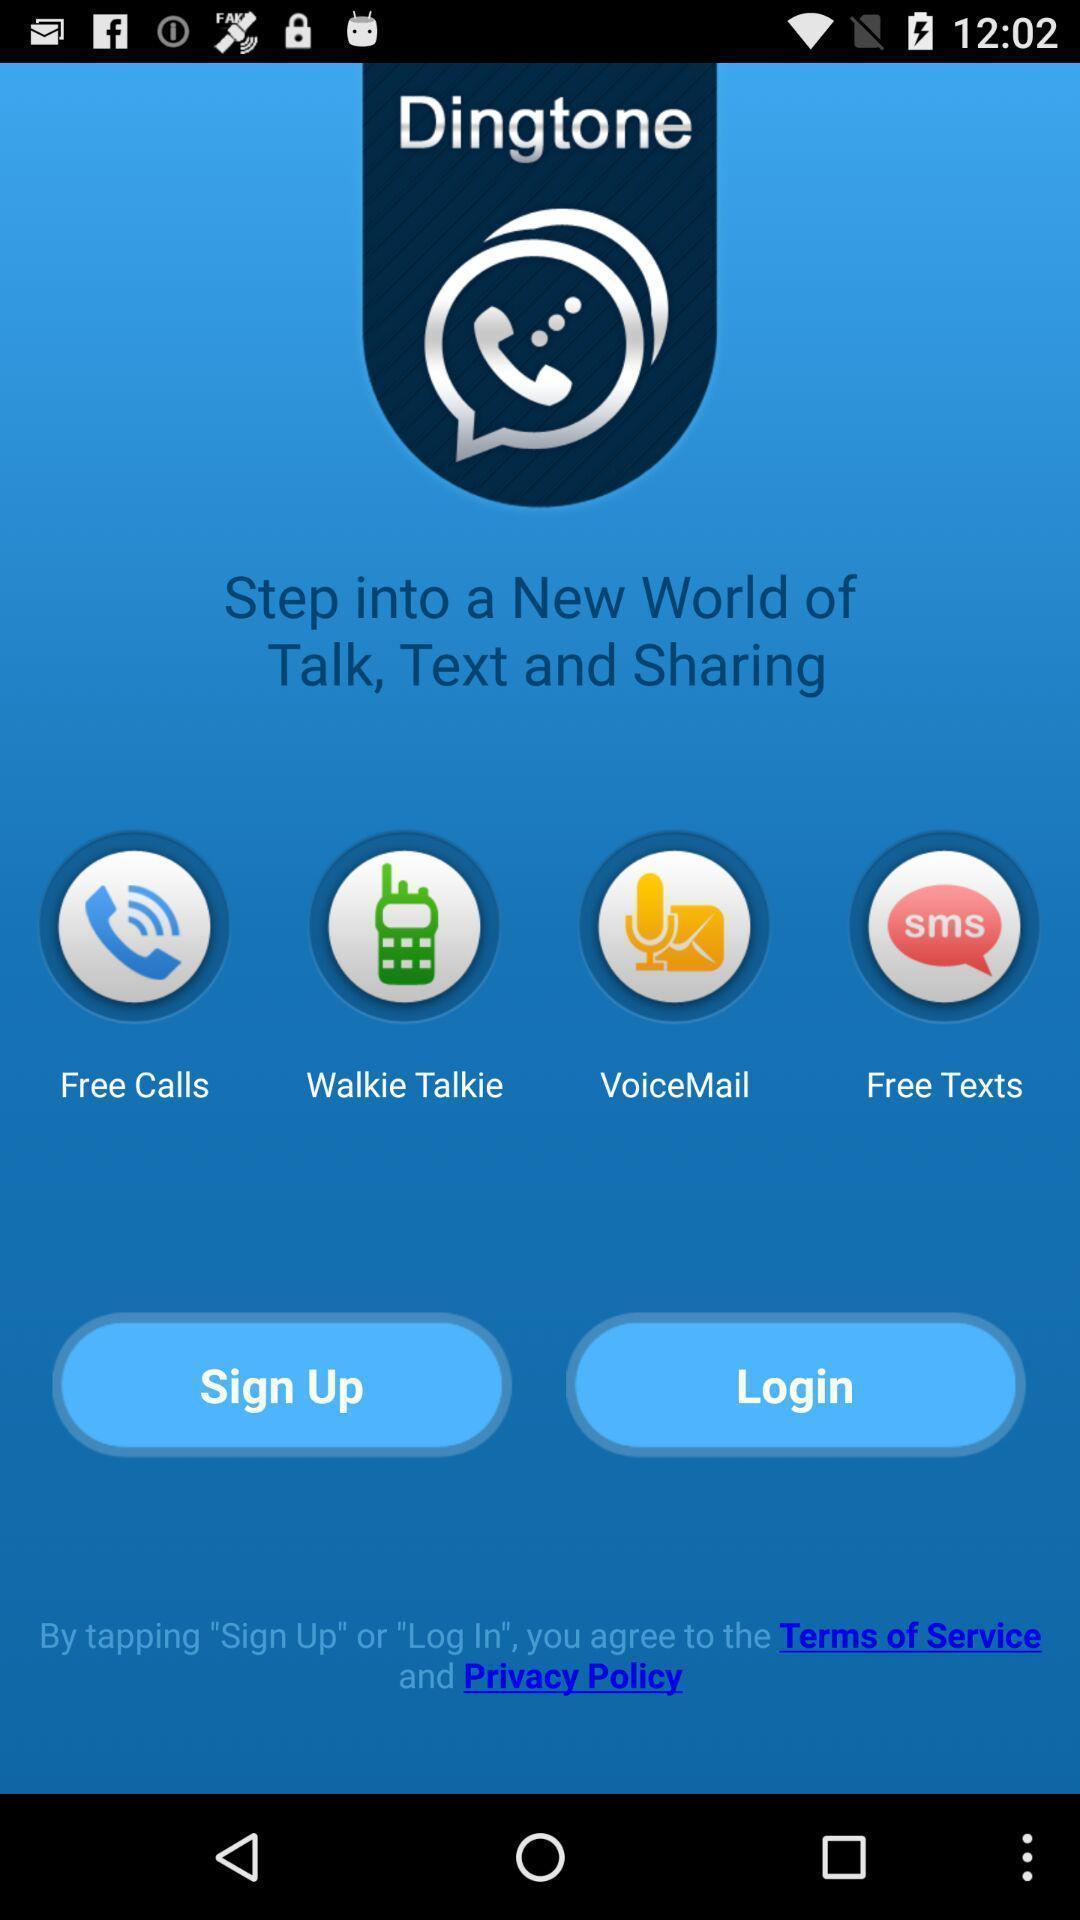Give me a summary of this screen capture. Sign up page of free calling app. 